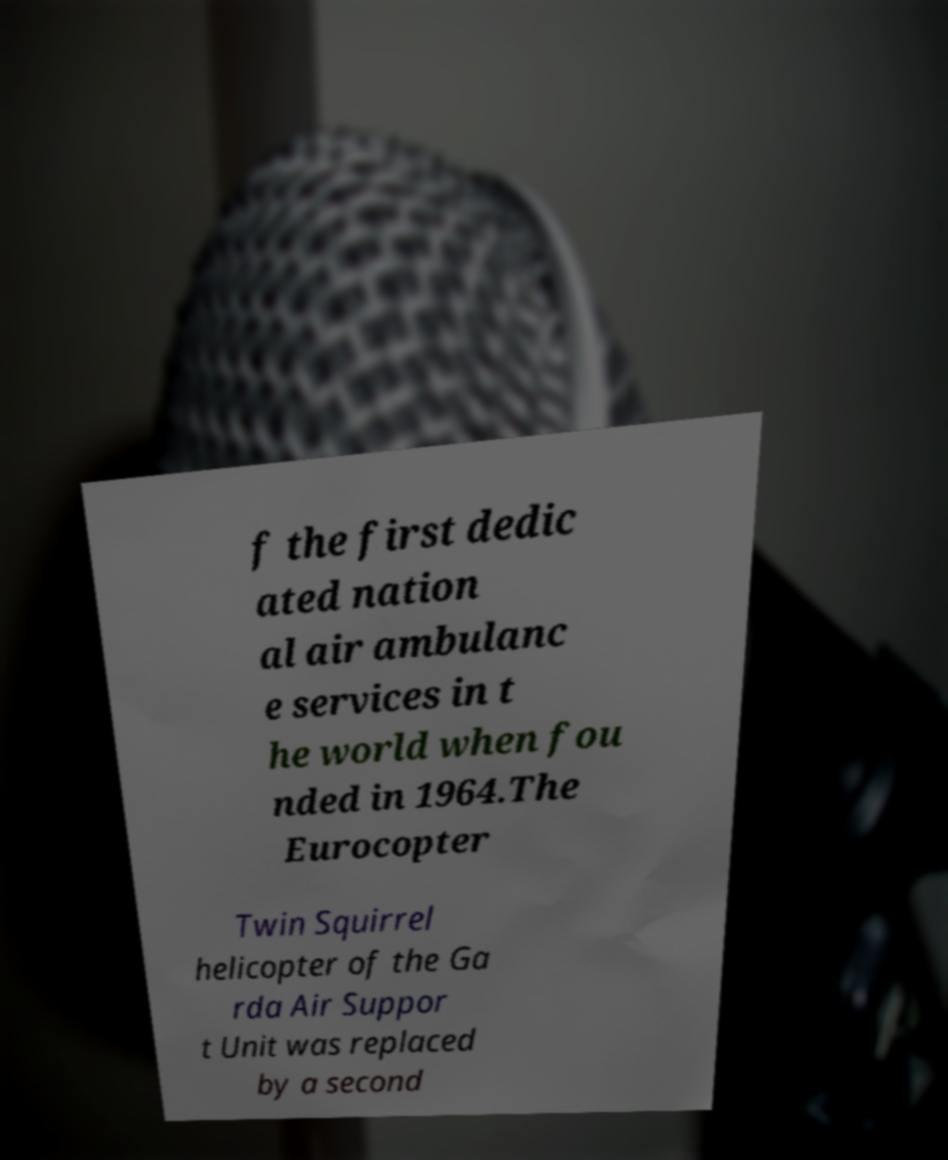Can you read and provide the text displayed in the image?This photo seems to have some interesting text. Can you extract and type it out for me? f the first dedic ated nation al air ambulanc e services in t he world when fou nded in 1964.The Eurocopter Twin Squirrel helicopter of the Ga rda Air Suppor t Unit was replaced by a second 